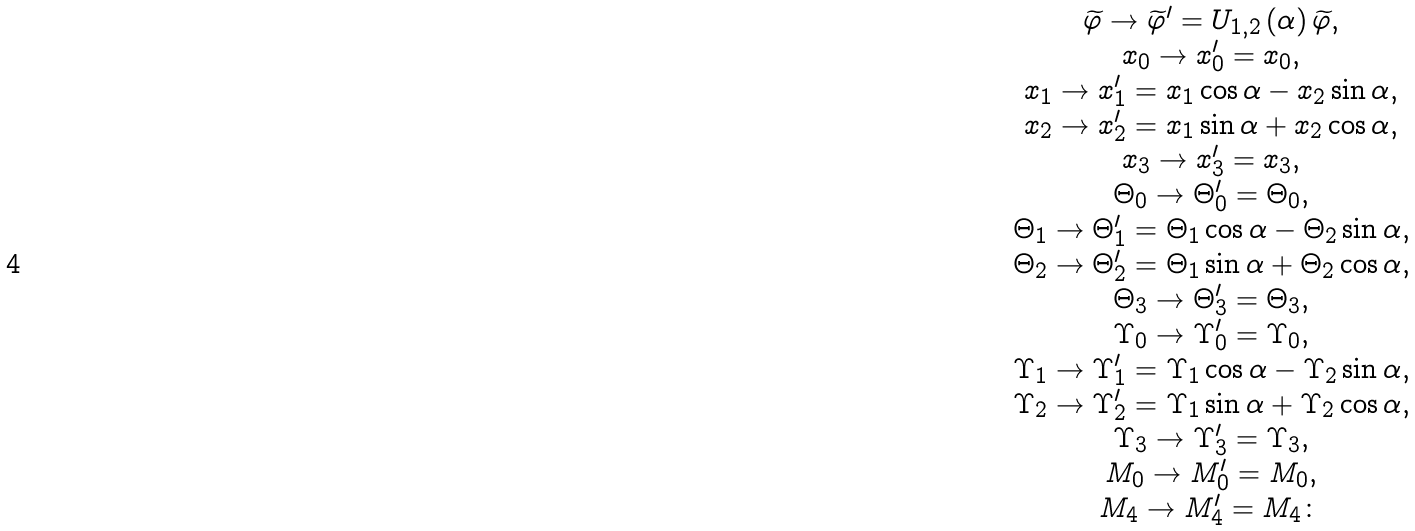Convert formula to latex. <formula><loc_0><loc_0><loc_500><loc_500>\begin{array} { c } \widetilde { \varphi } \rightarrow \widetilde { \varphi } ^ { \prime } = U _ { 1 , 2 } \left ( \alpha \right ) \widetilde { \varphi } , \\ x _ { 0 } \rightarrow x _ { 0 } ^ { \prime } = x _ { 0 } , \\ x _ { 1 } \rightarrow x _ { 1 } ^ { \prime } = x _ { 1 } \cos \alpha - x _ { 2 } \sin \alpha , \\ x _ { 2 } \rightarrow x _ { 2 } ^ { \prime } = x _ { 1 } \sin \alpha + x _ { 2 } \cos \alpha , \\ x _ { 3 } \rightarrow x _ { 3 } ^ { \prime } = x _ { 3 } , \\ \Theta _ { 0 } \rightarrow \Theta _ { 0 } ^ { \prime } = \Theta _ { 0 } , \\ \Theta _ { 1 } \rightarrow \Theta _ { 1 } ^ { \prime } = \Theta _ { 1 } \cos \alpha - \Theta _ { 2 } \sin \alpha , \\ \Theta _ { 2 } \rightarrow \Theta _ { 2 } ^ { \prime } = \Theta _ { 1 } \sin \alpha + \Theta _ { 2 } \cos \alpha , \\ \Theta _ { 3 } \rightarrow \Theta _ { 3 } ^ { \prime } = \Theta _ { 3 } , \\ \Upsilon _ { 0 } \rightarrow \Upsilon _ { 0 } ^ { \prime } = \Upsilon _ { 0 } , \\ \Upsilon _ { 1 } \rightarrow \Upsilon _ { 1 } ^ { \prime } = \Upsilon _ { 1 } \cos \alpha - \Upsilon _ { 2 } \sin \alpha , \\ \Upsilon _ { 2 } \rightarrow \Upsilon _ { 2 } ^ { \prime } = \Upsilon _ { 1 } \sin \alpha + \Upsilon _ { 2 } \cos \alpha , \\ \Upsilon _ { 3 } \rightarrow \Upsilon _ { 3 } ^ { \prime } = \Upsilon _ { 3 } , \\ M _ { 0 } \rightarrow M _ { 0 } ^ { \prime } = M _ { 0 } , \\ M _ { 4 } \rightarrow M _ { 4 } ^ { \prime } = M _ { 4 } \colon \end{array}</formula> 